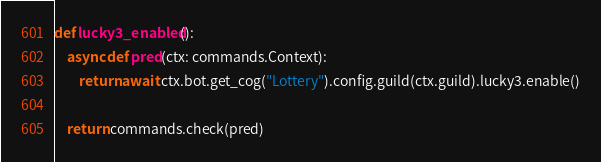<code> <loc_0><loc_0><loc_500><loc_500><_Python_>

def lucky3_enabled():
    async def pred(ctx: commands.Context):
        return await ctx.bot.get_cog("Lottery").config.guild(ctx.guild).lucky3.enable()

    return commands.check(pred)
</code> 